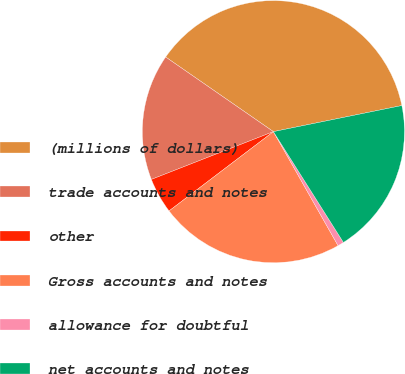Convert chart to OTSL. <chart><loc_0><loc_0><loc_500><loc_500><pie_chart><fcel>(millions of dollars)<fcel>trade accounts and notes<fcel>other<fcel>Gross accounts and notes<fcel>allowance for doubtful<fcel>net accounts and notes<nl><fcel>37.17%<fcel>15.58%<fcel>4.4%<fcel>22.87%<fcel>0.76%<fcel>19.22%<nl></chart> 